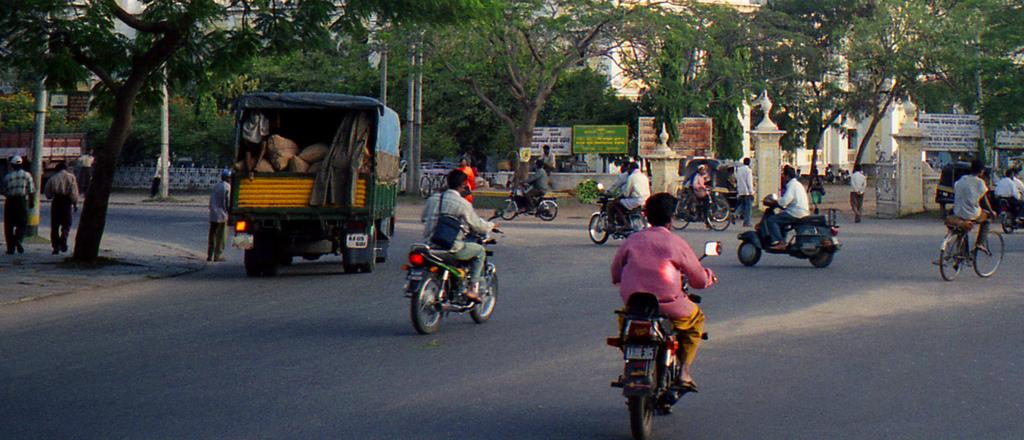What type of transportation can be seen in the image? There are bikes and vehicles in the image. Where are the bikes and vehicles located? They are on a road in the image. What else is happening on or near the road? People are walking by the side of the road. Can you tell me how many potatoes are on the road in the image? There are no potatoes present in the image; it features bikes, vehicles, and people walking. 